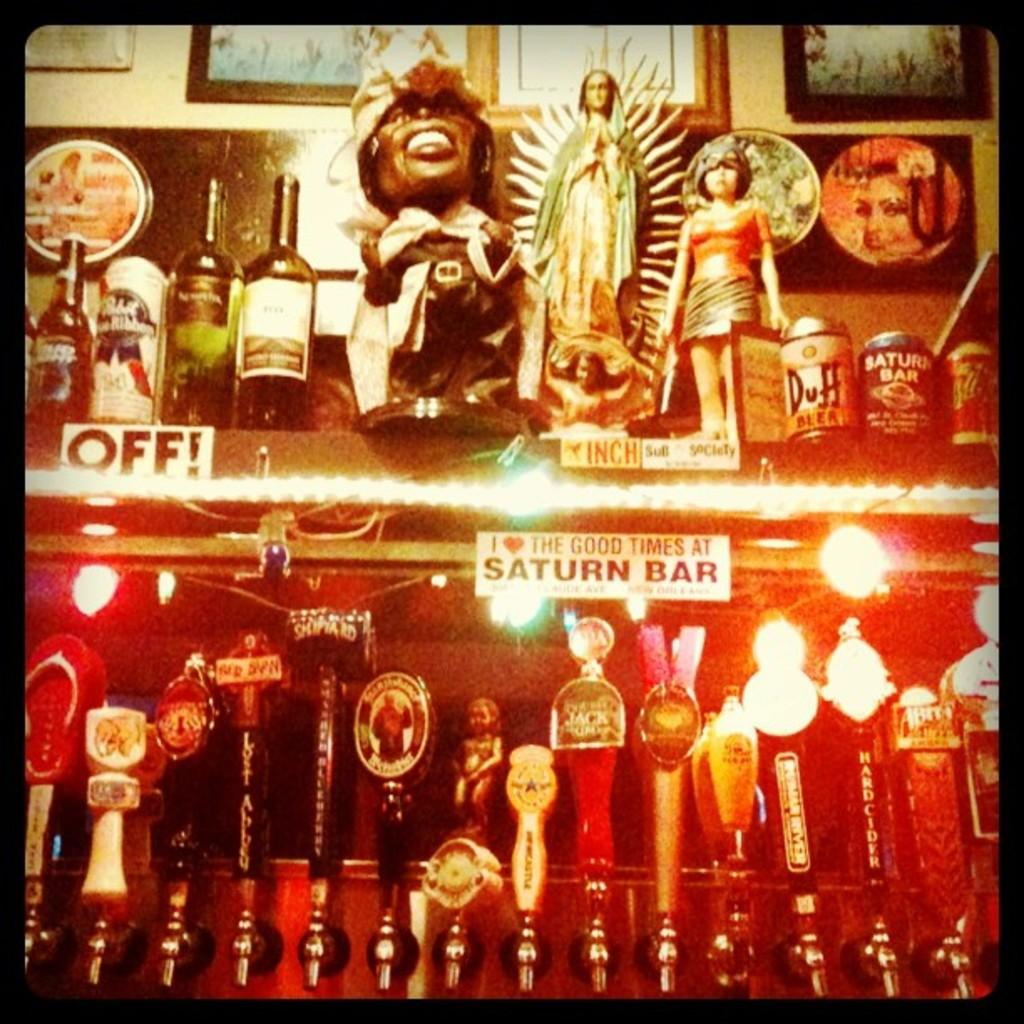<image>
Give a short and clear explanation of the subsequent image. A shelf has a printed not that has the word off and another mentions the Saturn Bar. 